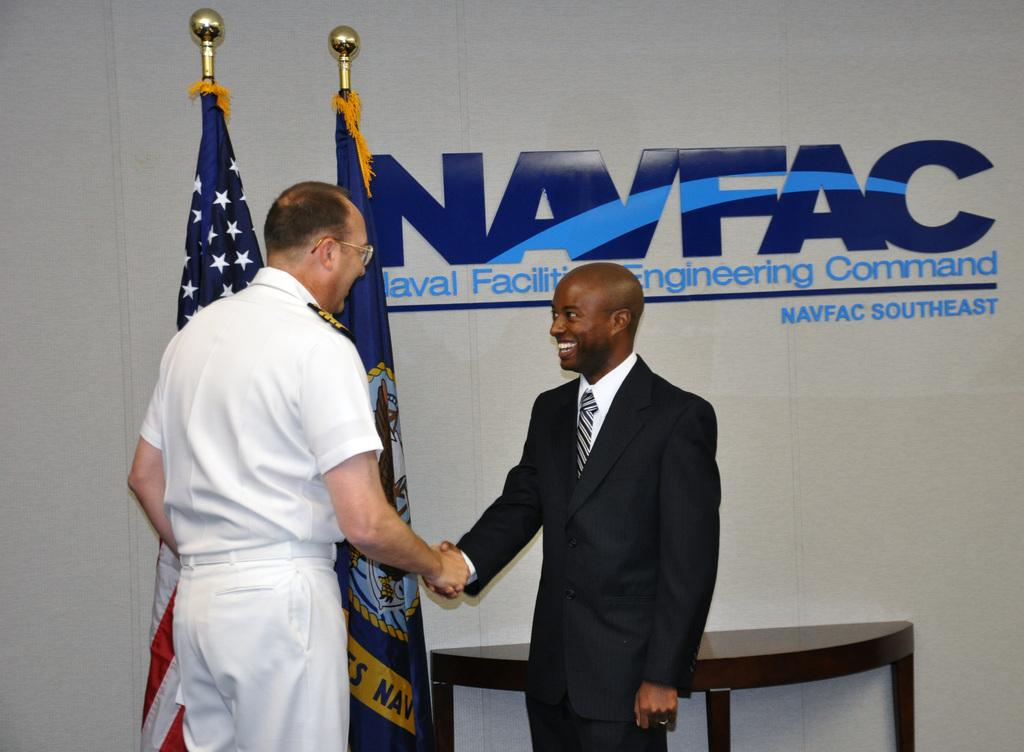<image>
Present a compact description of the photo's key features. Two men shake hands in front of a NAVFAC sign 